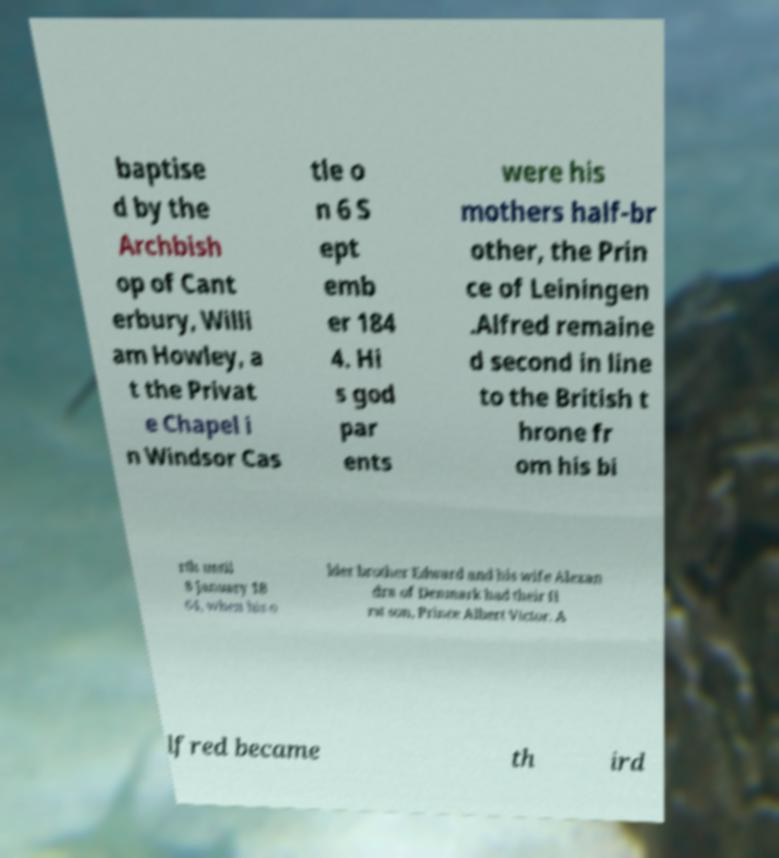I need the written content from this picture converted into text. Can you do that? baptise d by the Archbish op of Cant erbury, Willi am Howley, a t the Privat e Chapel i n Windsor Cas tle o n 6 S ept emb er 184 4. Hi s god par ents were his mothers half-br other, the Prin ce of Leiningen .Alfred remaine d second in line to the British t hrone fr om his bi rth until 8 January 18 64, when his o lder brother Edward and his wife Alexan dra of Denmark had their fi rst son, Prince Albert Victor. A lfred became th ird 